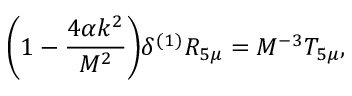Convert formula to latex. <formula><loc_0><loc_0><loc_500><loc_500>\left ( 1 - \frac { 4 \alpha k ^ { 2 } } { M ^ { 2 } } \right ) \delta ^ { ( 1 ) } R _ { 5 \mu } = M ^ { - 3 } T _ { 5 \mu } , \,</formula> 